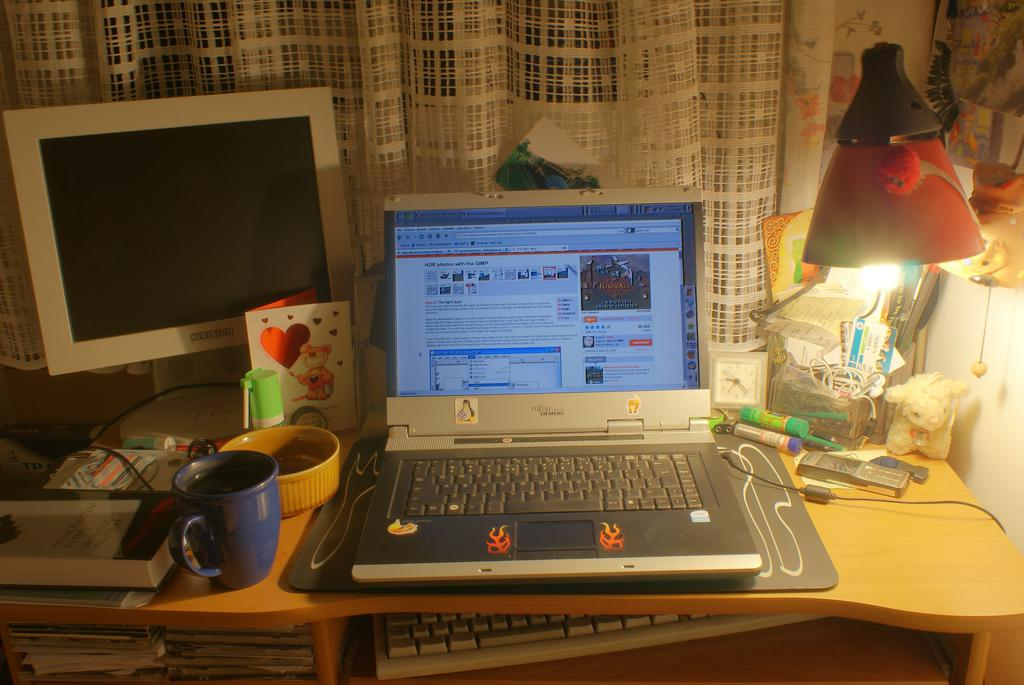Question: where was picture taken?
Choices:
A. Office.
B. At castle.
C. On bridge.
D. On ferry.
Answer with the letter. Answer: A Question: how many laptops are there?
Choices:
A. One.
B. Two.
C. Three.
D. Four.
Answer with the letter. Answer: A Question: when is the photo taken?
Choices:
A. Night time.
B. After sunset.
C. Before sunrise.
D. Midday.
Answer with the letter. Answer: A Question: where are many books?
Choices:
A. In the library.
B. On desk shelf.
C. On the chair.
D. On the table.
Answer with the letter. Answer: B Question: what is small,white and stuffed?
Choices:
A. Lamb.
B. Pillow.
C. Teddy bear.
D. Couch.
Answer with the letter. Answer: A Question: where is the photo taken?
Choices:
A. At a table.
B. At a desk.
C. On a bench.
D. At a counter.
Answer with the letter. Answer: B Question: what computer is active?
Choices:
A. The laptop.
B. The tablet.
C. The desktop.
D. The Apple.
Answer with the letter. Answer: A Question: who is in the photo?
Choices:
A. My family.
B. The dog.
C. No one.
D. My grandfather.
Answer with the letter. Answer: C Question: how does it look outside?
Choices:
A. Clear.
B. Overcast.
C. Gloomy.
D. Dark.
Answer with the letter. Answer: D Question: what color is the curtain?
Choices:
A. Blue.
B. Red.
C. Pink.
D. White.
Answer with the letter. Answer: D Question: what is on the desk?
Choices:
A. A spoon, fork, and knife.
B. A laptop and mouse.
C. A mug and a bowl.
D. Lotion and chapstick.
Answer with the letter. Answer: C Question: where is the blue cup?
Choices:
A. Next to the laptop.
B. Next to the mouse.
C. Next to the mouse pad.
D. Next to the package.
Answer with the letter. Answer: A Question: what is white?
Choices:
A. Dogs.
B. Coats.
C. Plates.
D. Clock.
Answer with the letter. Answer: D Question: what has two computers on it?
Choices:
A. Table.
B. Desk.
C. Couch.
D. Window sill.
Answer with the letter. Answer: B Question: why is the lamp turned on?
Choices:
A. To see in the dark.
B. To make the area visible.
C. To brighten up the room.
D. To see obstacles in path of travel.
Answer with the letter. Answer: A Question: what has very loose weave?
Choices:
A. Blanket.
B. Shawl.
C. Curtains.
D. Quilt.
Answer with the letter. Answer: C Question: what is white?
Choices:
A. Computer.
B. Phone.
C. Television.
D. Keyboard.
Answer with the letter. Answer: D Question: when was picture taken?
Choices:
A. Daytime.
B. Nighttime.
C. Lunch time.
D. Morning.
Answer with the letter. Answer: B Question: what is covering the window?
Choices:
A. Blue drapes.
B. Orange translucent curtains.
C. White mesh curtains.
D. White dirty blinds.
Answer with the letter. Answer: C 